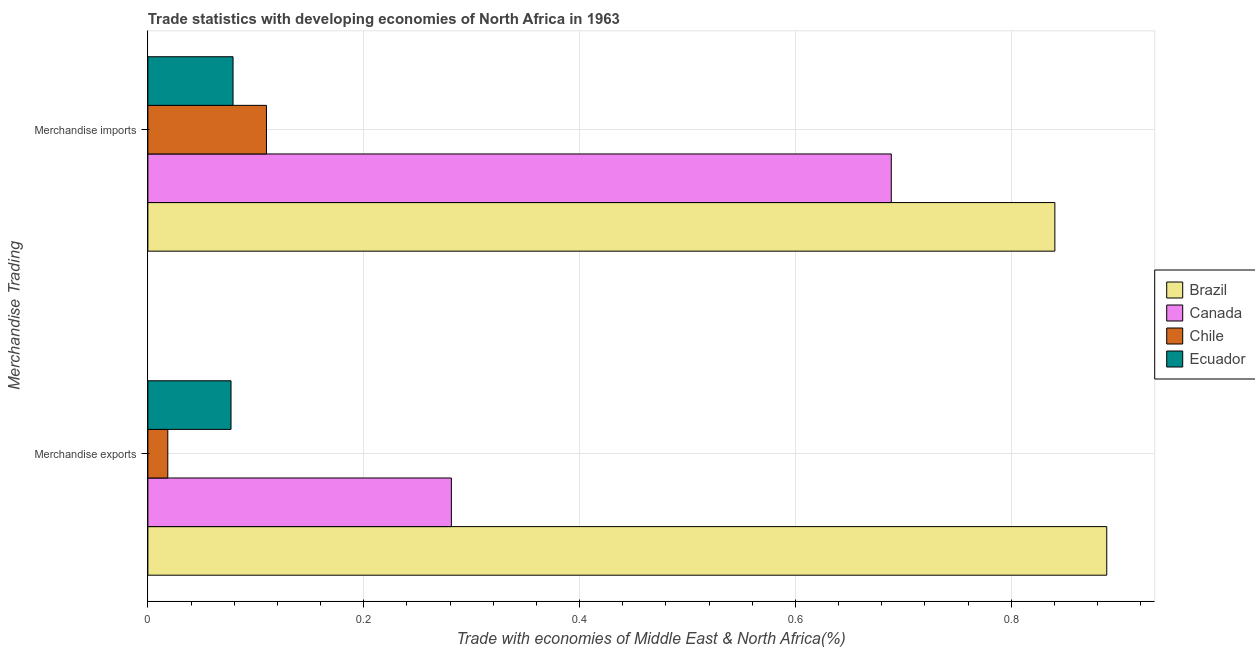How many bars are there on the 1st tick from the bottom?
Your answer should be very brief. 4. What is the label of the 2nd group of bars from the top?
Give a very brief answer. Merchandise exports. What is the merchandise imports in Ecuador?
Keep it short and to the point. 0.08. Across all countries, what is the maximum merchandise imports?
Provide a succinct answer. 0.84. Across all countries, what is the minimum merchandise imports?
Ensure brevity in your answer.  0.08. In which country was the merchandise exports maximum?
Make the answer very short. Brazil. In which country was the merchandise exports minimum?
Provide a short and direct response. Chile. What is the total merchandise exports in the graph?
Your response must be concise. 1.27. What is the difference between the merchandise imports in Brazil and that in Canada?
Your answer should be compact. 0.15. What is the difference between the merchandise exports in Canada and the merchandise imports in Brazil?
Provide a succinct answer. -0.56. What is the average merchandise exports per country?
Provide a succinct answer. 0.32. What is the difference between the merchandise exports and merchandise imports in Canada?
Give a very brief answer. -0.41. In how many countries, is the merchandise imports greater than 0.44 %?
Provide a short and direct response. 2. What is the ratio of the merchandise exports in Chile to that in Ecuador?
Your response must be concise. 0.24. Is the merchandise exports in Brazil less than that in Canada?
Ensure brevity in your answer.  No. In how many countries, is the merchandise imports greater than the average merchandise imports taken over all countries?
Offer a very short reply. 2. What does the 4th bar from the top in Merchandise exports represents?
Your response must be concise. Brazil. Are all the bars in the graph horizontal?
Provide a succinct answer. Yes. Are the values on the major ticks of X-axis written in scientific E-notation?
Provide a short and direct response. No. Does the graph contain any zero values?
Provide a short and direct response. No. Where does the legend appear in the graph?
Keep it short and to the point. Center right. What is the title of the graph?
Your answer should be compact. Trade statistics with developing economies of North Africa in 1963. Does "Spain" appear as one of the legend labels in the graph?
Keep it short and to the point. No. What is the label or title of the X-axis?
Provide a short and direct response. Trade with economies of Middle East & North Africa(%). What is the label or title of the Y-axis?
Make the answer very short. Merchandise Trading. What is the Trade with economies of Middle East & North Africa(%) of Brazil in Merchandise exports?
Your response must be concise. 0.89. What is the Trade with economies of Middle East & North Africa(%) in Canada in Merchandise exports?
Provide a short and direct response. 0.28. What is the Trade with economies of Middle East & North Africa(%) of Chile in Merchandise exports?
Your response must be concise. 0.02. What is the Trade with economies of Middle East & North Africa(%) in Ecuador in Merchandise exports?
Ensure brevity in your answer.  0.08. What is the Trade with economies of Middle East & North Africa(%) in Brazil in Merchandise imports?
Offer a very short reply. 0.84. What is the Trade with economies of Middle East & North Africa(%) of Canada in Merchandise imports?
Offer a terse response. 0.69. What is the Trade with economies of Middle East & North Africa(%) of Chile in Merchandise imports?
Provide a short and direct response. 0.11. What is the Trade with economies of Middle East & North Africa(%) of Ecuador in Merchandise imports?
Ensure brevity in your answer.  0.08. Across all Merchandise Trading, what is the maximum Trade with economies of Middle East & North Africa(%) of Brazil?
Ensure brevity in your answer.  0.89. Across all Merchandise Trading, what is the maximum Trade with economies of Middle East & North Africa(%) in Canada?
Make the answer very short. 0.69. Across all Merchandise Trading, what is the maximum Trade with economies of Middle East & North Africa(%) of Chile?
Provide a succinct answer. 0.11. Across all Merchandise Trading, what is the maximum Trade with economies of Middle East & North Africa(%) in Ecuador?
Keep it short and to the point. 0.08. Across all Merchandise Trading, what is the minimum Trade with economies of Middle East & North Africa(%) in Brazil?
Provide a succinct answer. 0.84. Across all Merchandise Trading, what is the minimum Trade with economies of Middle East & North Africa(%) of Canada?
Provide a short and direct response. 0.28. Across all Merchandise Trading, what is the minimum Trade with economies of Middle East & North Africa(%) in Chile?
Give a very brief answer. 0.02. Across all Merchandise Trading, what is the minimum Trade with economies of Middle East & North Africa(%) of Ecuador?
Make the answer very short. 0.08. What is the total Trade with economies of Middle East & North Africa(%) of Brazil in the graph?
Your answer should be compact. 1.73. What is the total Trade with economies of Middle East & North Africa(%) in Canada in the graph?
Your answer should be compact. 0.97. What is the total Trade with economies of Middle East & North Africa(%) in Chile in the graph?
Keep it short and to the point. 0.13. What is the total Trade with economies of Middle East & North Africa(%) of Ecuador in the graph?
Provide a short and direct response. 0.16. What is the difference between the Trade with economies of Middle East & North Africa(%) of Brazil in Merchandise exports and that in Merchandise imports?
Give a very brief answer. 0.05. What is the difference between the Trade with economies of Middle East & North Africa(%) in Canada in Merchandise exports and that in Merchandise imports?
Give a very brief answer. -0.41. What is the difference between the Trade with economies of Middle East & North Africa(%) of Chile in Merchandise exports and that in Merchandise imports?
Keep it short and to the point. -0.09. What is the difference between the Trade with economies of Middle East & North Africa(%) of Ecuador in Merchandise exports and that in Merchandise imports?
Provide a succinct answer. -0. What is the difference between the Trade with economies of Middle East & North Africa(%) of Brazil in Merchandise exports and the Trade with economies of Middle East & North Africa(%) of Canada in Merchandise imports?
Provide a short and direct response. 0.2. What is the difference between the Trade with economies of Middle East & North Africa(%) of Brazil in Merchandise exports and the Trade with economies of Middle East & North Africa(%) of Chile in Merchandise imports?
Give a very brief answer. 0.78. What is the difference between the Trade with economies of Middle East & North Africa(%) of Brazil in Merchandise exports and the Trade with economies of Middle East & North Africa(%) of Ecuador in Merchandise imports?
Provide a short and direct response. 0.81. What is the difference between the Trade with economies of Middle East & North Africa(%) in Canada in Merchandise exports and the Trade with economies of Middle East & North Africa(%) in Chile in Merchandise imports?
Offer a terse response. 0.17. What is the difference between the Trade with economies of Middle East & North Africa(%) in Canada in Merchandise exports and the Trade with economies of Middle East & North Africa(%) in Ecuador in Merchandise imports?
Offer a terse response. 0.2. What is the difference between the Trade with economies of Middle East & North Africa(%) in Chile in Merchandise exports and the Trade with economies of Middle East & North Africa(%) in Ecuador in Merchandise imports?
Provide a short and direct response. -0.06. What is the average Trade with economies of Middle East & North Africa(%) in Brazil per Merchandise Trading?
Offer a very short reply. 0.86. What is the average Trade with economies of Middle East & North Africa(%) of Canada per Merchandise Trading?
Offer a very short reply. 0.48. What is the average Trade with economies of Middle East & North Africa(%) in Chile per Merchandise Trading?
Keep it short and to the point. 0.06. What is the average Trade with economies of Middle East & North Africa(%) of Ecuador per Merchandise Trading?
Offer a very short reply. 0.08. What is the difference between the Trade with economies of Middle East & North Africa(%) of Brazil and Trade with economies of Middle East & North Africa(%) of Canada in Merchandise exports?
Offer a terse response. 0.61. What is the difference between the Trade with economies of Middle East & North Africa(%) of Brazil and Trade with economies of Middle East & North Africa(%) of Chile in Merchandise exports?
Ensure brevity in your answer.  0.87. What is the difference between the Trade with economies of Middle East & North Africa(%) of Brazil and Trade with economies of Middle East & North Africa(%) of Ecuador in Merchandise exports?
Ensure brevity in your answer.  0.81. What is the difference between the Trade with economies of Middle East & North Africa(%) of Canada and Trade with economies of Middle East & North Africa(%) of Chile in Merchandise exports?
Offer a terse response. 0.26. What is the difference between the Trade with economies of Middle East & North Africa(%) in Canada and Trade with economies of Middle East & North Africa(%) in Ecuador in Merchandise exports?
Your response must be concise. 0.2. What is the difference between the Trade with economies of Middle East & North Africa(%) in Chile and Trade with economies of Middle East & North Africa(%) in Ecuador in Merchandise exports?
Provide a short and direct response. -0.06. What is the difference between the Trade with economies of Middle East & North Africa(%) of Brazil and Trade with economies of Middle East & North Africa(%) of Canada in Merchandise imports?
Provide a short and direct response. 0.15. What is the difference between the Trade with economies of Middle East & North Africa(%) of Brazil and Trade with economies of Middle East & North Africa(%) of Chile in Merchandise imports?
Provide a succinct answer. 0.73. What is the difference between the Trade with economies of Middle East & North Africa(%) of Brazil and Trade with economies of Middle East & North Africa(%) of Ecuador in Merchandise imports?
Give a very brief answer. 0.76. What is the difference between the Trade with economies of Middle East & North Africa(%) in Canada and Trade with economies of Middle East & North Africa(%) in Chile in Merchandise imports?
Offer a terse response. 0.58. What is the difference between the Trade with economies of Middle East & North Africa(%) of Canada and Trade with economies of Middle East & North Africa(%) of Ecuador in Merchandise imports?
Keep it short and to the point. 0.61. What is the difference between the Trade with economies of Middle East & North Africa(%) in Chile and Trade with economies of Middle East & North Africa(%) in Ecuador in Merchandise imports?
Offer a terse response. 0.03. What is the ratio of the Trade with economies of Middle East & North Africa(%) in Brazil in Merchandise exports to that in Merchandise imports?
Offer a very short reply. 1.06. What is the ratio of the Trade with economies of Middle East & North Africa(%) of Canada in Merchandise exports to that in Merchandise imports?
Provide a succinct answer. 0.41. What is the ratio of the Trade with economies of Middle East & North Africa(%) in Chile in Merchandise exports to that in Merchandise imports?
Your answer should be very brief. 0.17. What is the ratio of the Trade with economies of Middle East & North Africa(%) in Ecuador in Merchandise exports to that in Merchandise imports?
Give a very brief answer. 0.98. What is the difference between the highest and the second highest Trade with economies of Middle East & North Africa(%) of Brazil?
Give a very brief answer. 0.05. What is the difference between the highest and the second highest Trade with economies of Middle East & North Africa(%) in Canada?
Give a very brief answer. 0.41. What is the difference between the highest and the second highest Trade with economies of Middle East & North Africa(%) of Chile?
Your answer should be very brief. 0.09. What is the difference between the highest and the second highest Trade with economies of Middle East & North Africa(%) of Ecuador?
Offer a terse response. 0. What is the difference between the highest and the lowest Trade with economies of Middle East & North Africa(%) in Brazil?
Offer a terse response. 0.05. What is the difference between the highest and the lowest Trade with economies of Middle East & North Africa(%) in Canada?
Your answer should be compact. 0.41. What is the difference between the highest and the lowest Trade with economies of Middle East & North Africa(%) of Chile?
Ensure brevity in your answer.  0.09. What is the difference between the highest and the lowest Trade with economies of Middle East & North Africa(%) in Ecuador?
Provide a succinct answer. 0. 